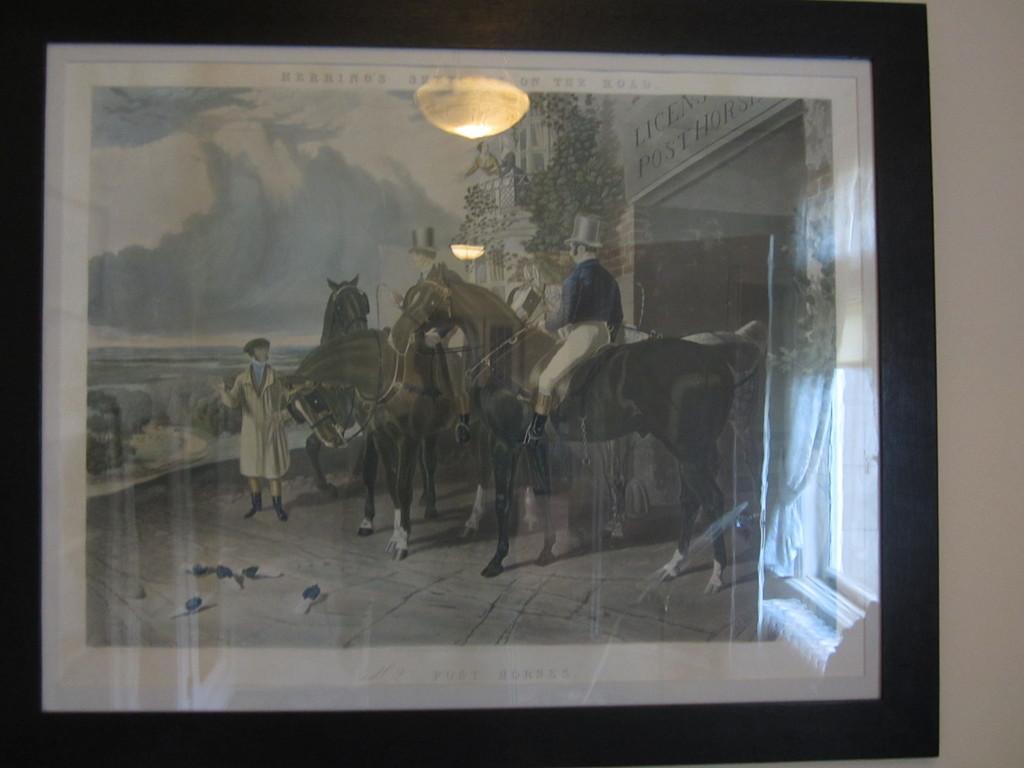In one or two sentences, can you explain what this image depicts? In this image there is a painting. In the painting there are horses. A person is sitting on a horse. Here a person is standing. On the ground there are birds. This is looking like an entrance. On the top there are lights. In the left there is a water body. The sky is cloudy. There are plants on the building. 